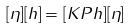Convert formula to latex. <formula><loc_0><loc_0><loc_500><loc_500>[ \eta ] [ h ] = [ K P h ] [ \eta ]</formula> 